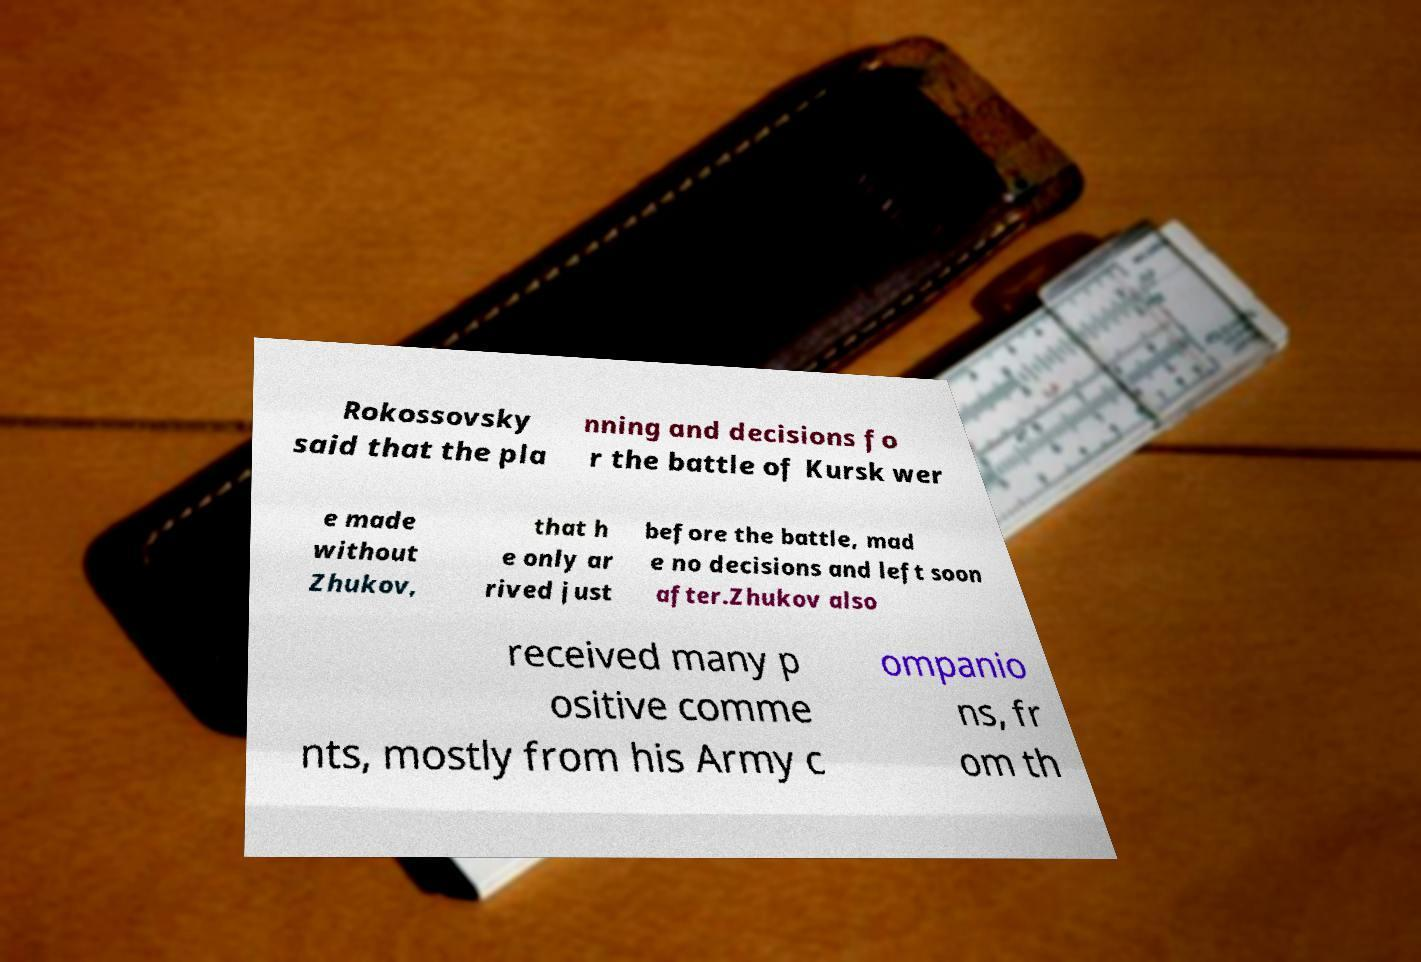Could you assist in decoding the text presented in this image and type it out clearly? Rokossovsky said that the pla nning and decisions fo r the battle of Kursk wer e made without Zhukov, that h e only ar rived just before the battle, mad e no decisions and left soon after.Zhukov also received many p ositive comme nts, mostly from his Army c ompanio ns, fr om th 